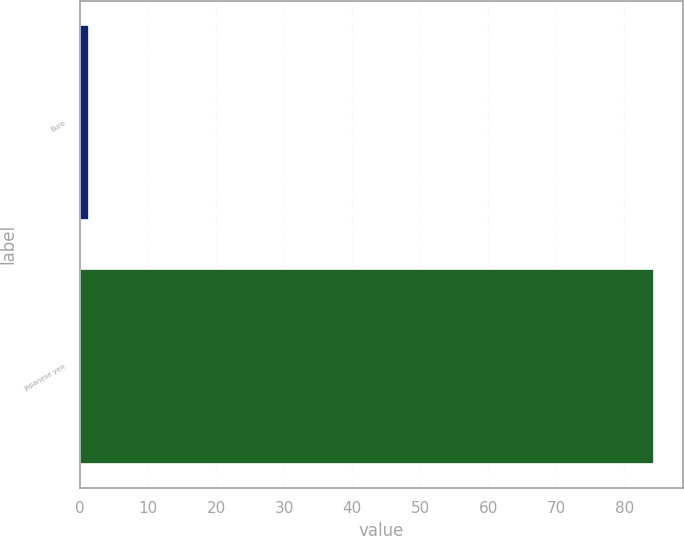<chart> <loc_0><loc_0><loc_500><loc_500><bar_chart><fcel>Euro<fcel>Japanese yen<nl><fcel>1.31<fcel>84.4<nl></chart> 